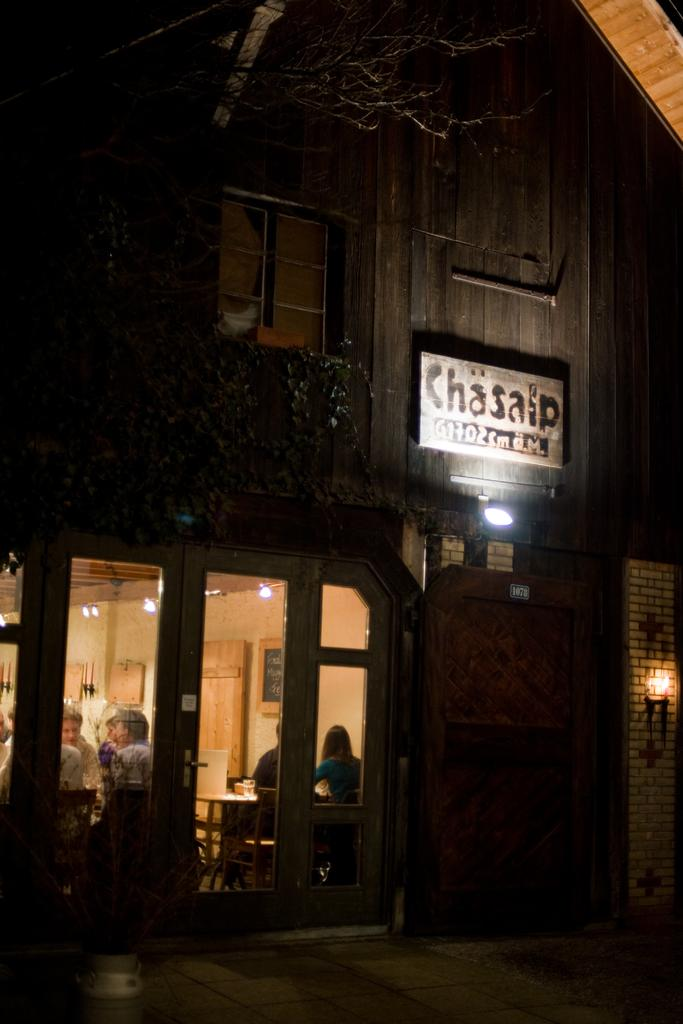<image>
Offer a succinct explanation of the picture presented. a sign above a door outside of a building that says 'chasalp' 